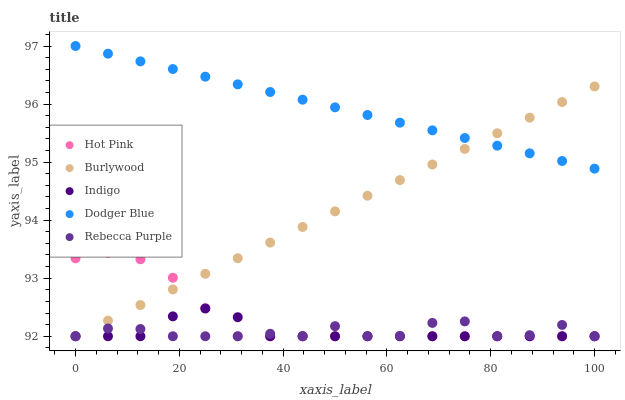Does Indigo have the minimum area under the curve?
Answer yes or no. Yes. Does Dodger Blue have the maximum area under the curve?
Answer yes or no. Yes. Does Hot Pink have the minimum area under the curve?
Answer yes or no. No. Does Hot Pink have the maximum area under the curve?
Answer yes or no. No. Is Burlywood the smoothest?
Answer yes or no. Yes. Is Rebecca Purple the roughest?
Answer yes or no. Yes. Is Dodger Blue the smoothest?
Answer yes or no. No. Is Dodger Blue the roughest?
Answer yes or no. No. Does Burlywood have the lowest value?
Answer yes or no. Yes. Does Dodger Blue have the lowest value?
Answer yes or no. No. Does Dodger Blue have the highest value?
Answer yes or no. Yes. Does Hot Pink have the highest value?
Answer yes or no. No. Is Hot Pink less than Dodger Blue?
Answer yes or no. Yes. Is Dodger Blue greater than Rebecca Purple?
Answer yes or no. Yes. Does Rebecca Purple intersect Burlywood?
Answer yes or no. Yes. Is Rebecca Purple less than Burlywood?
Answer yes or no. No. Is Rebecca Purple greater than Burlywood?
Answer yes or no. No. Does Hot Pink intersect Dodger Blue?
Answer yes or no. No. 